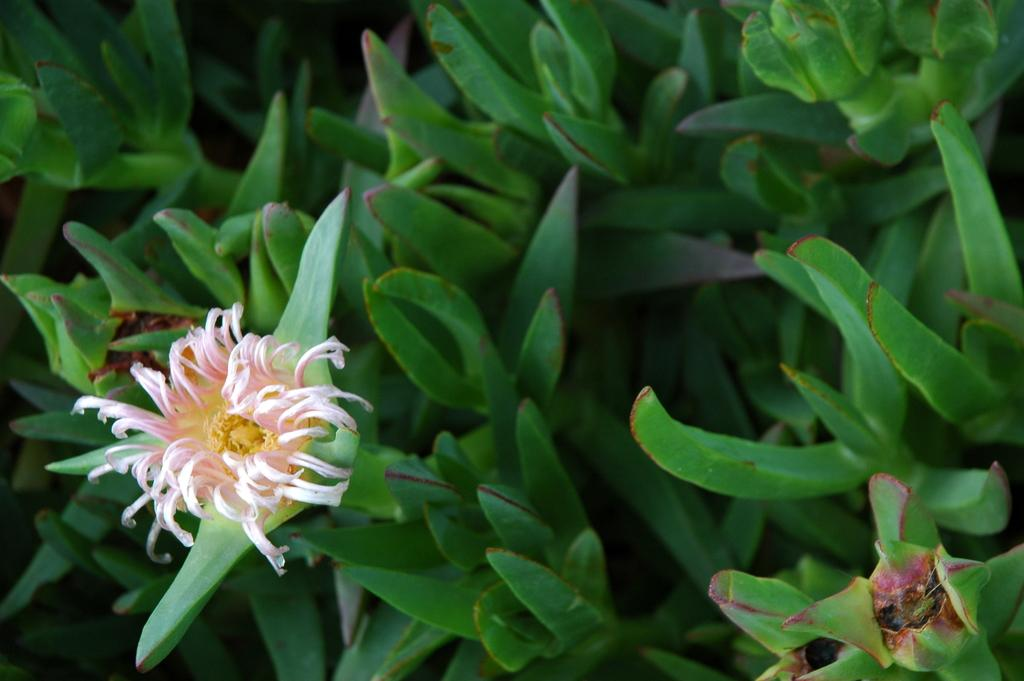What type of plants are visible in the image? There are houseplants in the image. What color are the houseplants? The houseplants are green in color. Can you describe any specific features of the houseplants? Yes, there is a flower on one of the plants. What type of quilt is draped over the houseplants in the image? There is no quilt present in the image; it only features houseplants. Can you describe the air quality in the room where the houseplants are located? The provided facts do not give any information about the air quality in the room, so it cannot be determined from the image. 